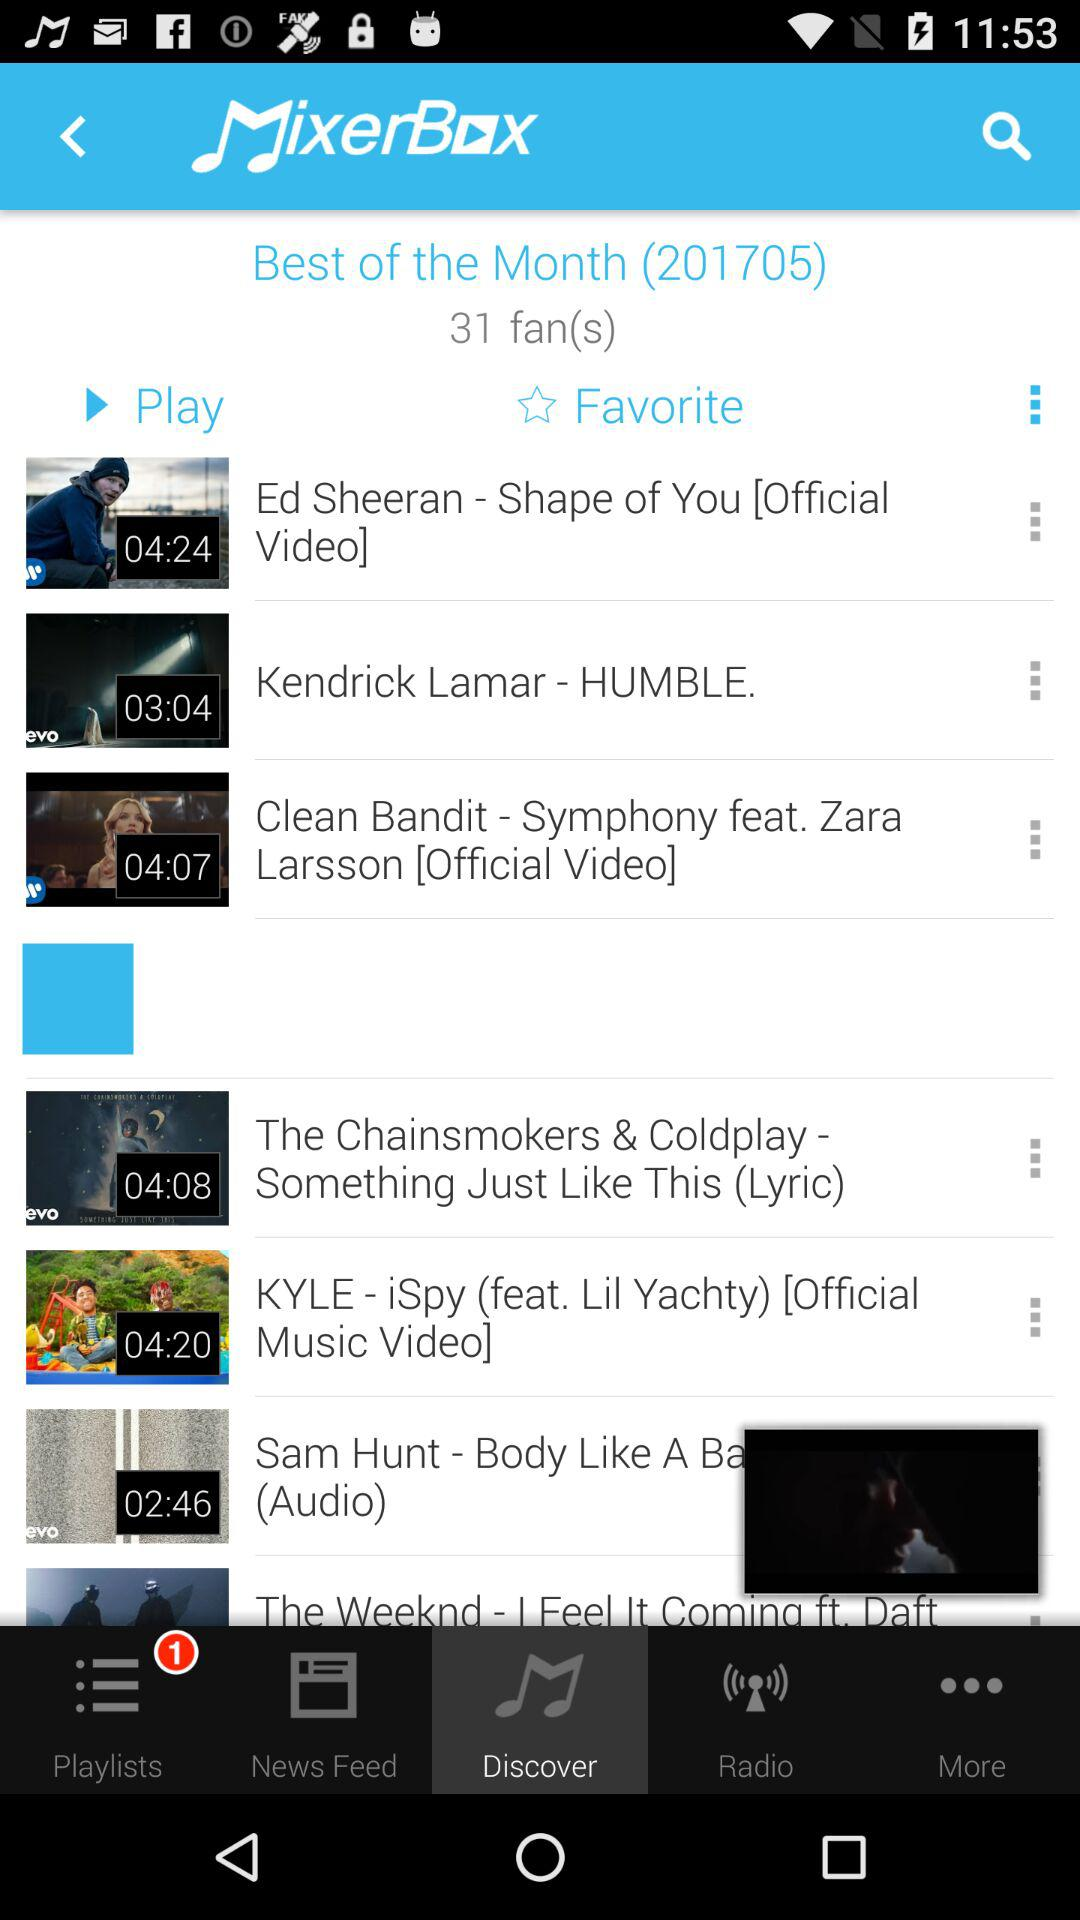Which option is selected? The selected option is "Discover". 